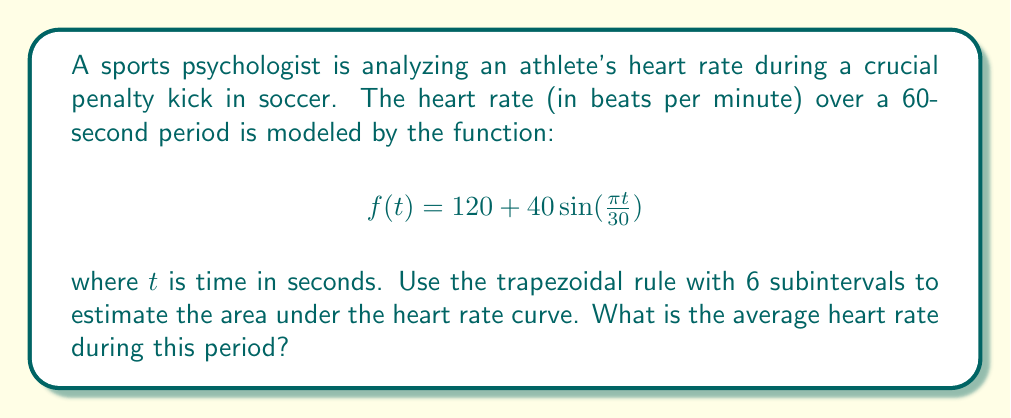Teach me how to tackle this problem. 1) The trapezoidal rule for numerical integration is given by:

   $$\int_{a}^{b} f(x)dx \approx \frac{h}{2}[f(x_0) + 2f(x_1) + 2f(x_2) + ... + 2f(x_{n-1}) + f(x_n)]$$

   where $h = \frac{b-a}{n}$, and $n$ is the number of subintervals.

2) Here, $a=0$, $b=60$, and $n=6$. So, $h = \frac{60-0}{6} = 10$.

3) We need to calculate $f(t)$ at $t = 0, 10, 20, 30, 40, 50, 60$:

   $f(0) = 120 + 40\sin(0) = 120$
   $f(10) = 120 + 40\sin(\frac{\pi}{3}) \approx 154.64$
   $f(20) = 120 + 40\sin(\frac{2\pi}{3}) \approx 154.64$
   $f(30) = 120 + 40\sin(\pi) = 120$
   $f(40) = 120 + 40\sin(\frac{4\pi}{3}) \approx 85.36$
   $f(50) = 120 + 40\sin(\frac{5\pi}{3}) \approx 85.36$
   $f(60) = 120 + 40\sin(2\pi) = 120$

4) Applying the trapezoidal rule:

   $$\text{Area} \approx \frac{10}{2}[120 + 2(154.64 + 154.64 + 120 + 85.36 + 85.36) + 120]$$
   $$= 5[120 + 2(700) + 120] = 5[120 + 1400 + 120] = 5(1640) = 8200$$

5) To find the average heart rate, divide the area by the time period:

   Average Heart Rate = $\frac{8200}{60} \approx 136.67$ beats per minute
Answer: 136.67 bpm 